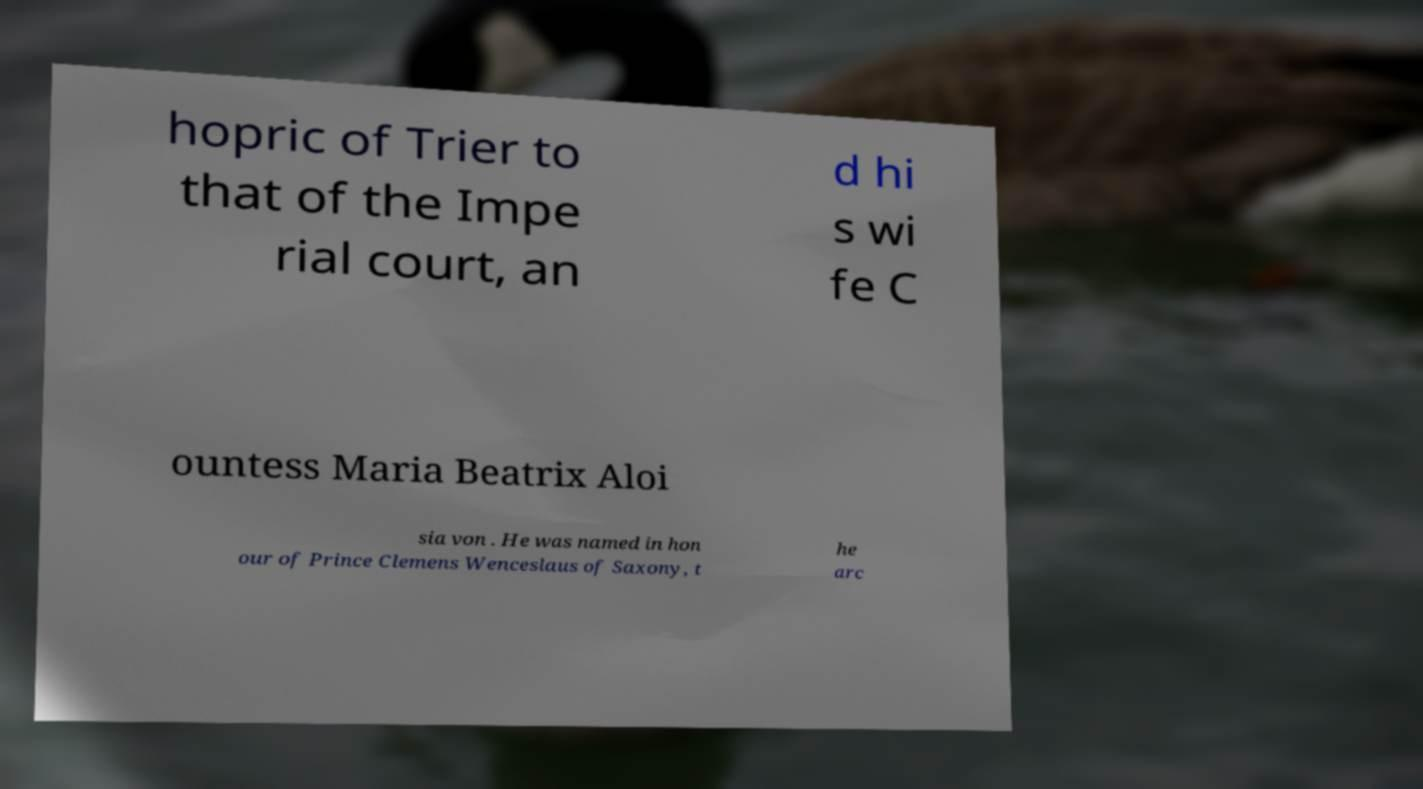Can you accurately transcribe the text from the provided image for me? hopric of Trier to that of the Impe rial court, an d hi s wi fe C ountess Maria Beatrix Aloi sia von . He was named in hon our of Prince Clemens Wenceslaus of Saxony, t he arc 